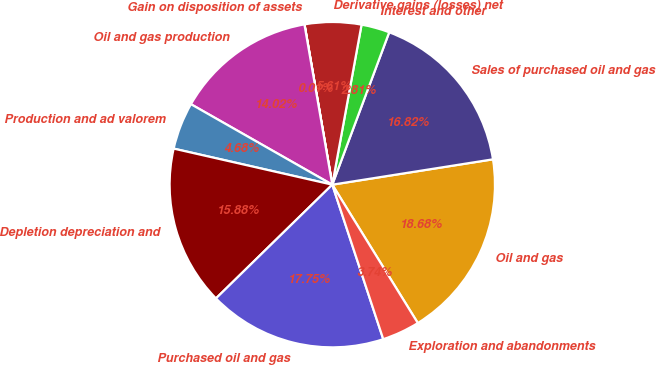<chart> <loc_0><loc_0><loc_500><loc_500><pie_chart><fcel>Oil and gas<fcel>Sales of purchased oil and gas<fcel>Interest and other<fcel>Derivative gains (losses) net<fcel>Gain on disposition of assets<fcel>Oil and gas production<fcel>Production and ad valorem<fcel>Depletion depreciation and<fcel>Purchased oil and gas<fcel>Exploration and abandonments<nl><fcel>18.68%<fcel>16.82%<fcel>2.81%<fcel>5.61%<fcel>0.01%<fcel>14.02%<fcel>4.68%<fcel>15.88%<fcel>17.75%<fcel>3.74%<nl></chart> 